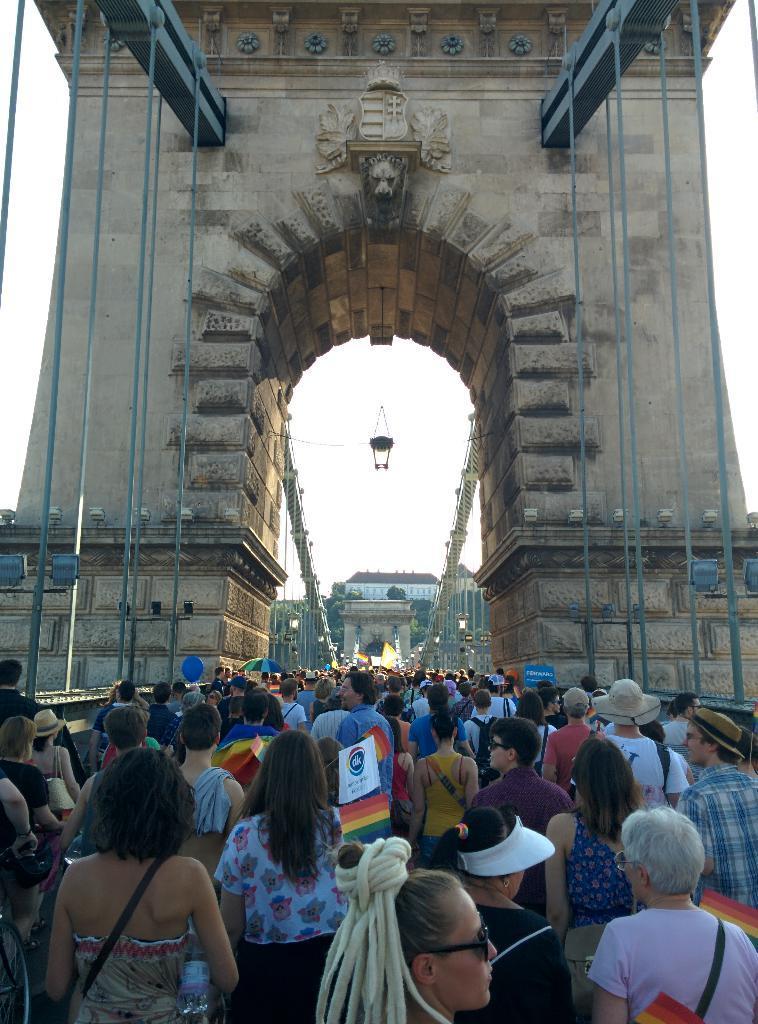In one or two sentences, can you explain what this image depicts? In this image I can see number of persons are standing on the bridge and I can see a cream colored structure and few metal objects which are blue in color. In the background I can see few trees, few buildings and the sky. 